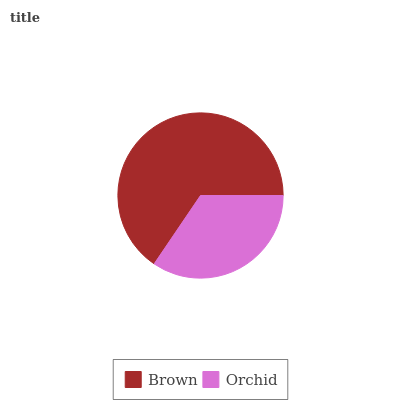Is Orchid the minimum?
Answer yes or no. Yes. Is Brown the maximum?
Answer yes or no. Yes. Is Orchid the maximum?
Answer yes or no. No. Is Brown greater than Orchid?
Answer yes or no. Yes. Is Orchid less than Brown?
Answer yes or no. Yes. Is Orchid greater than Brown?
Answer yes or no. No. Is Brown less than Orchid?
Answer yes or no. No. Is Brown the high median?
Answer yes or no. Yes. Is Orchid the low median?
Answer yes or no. Yes. Is Orchid the high median?
Answer yes or no. No. Is Brown the low median?
Answer yes or no. No. 